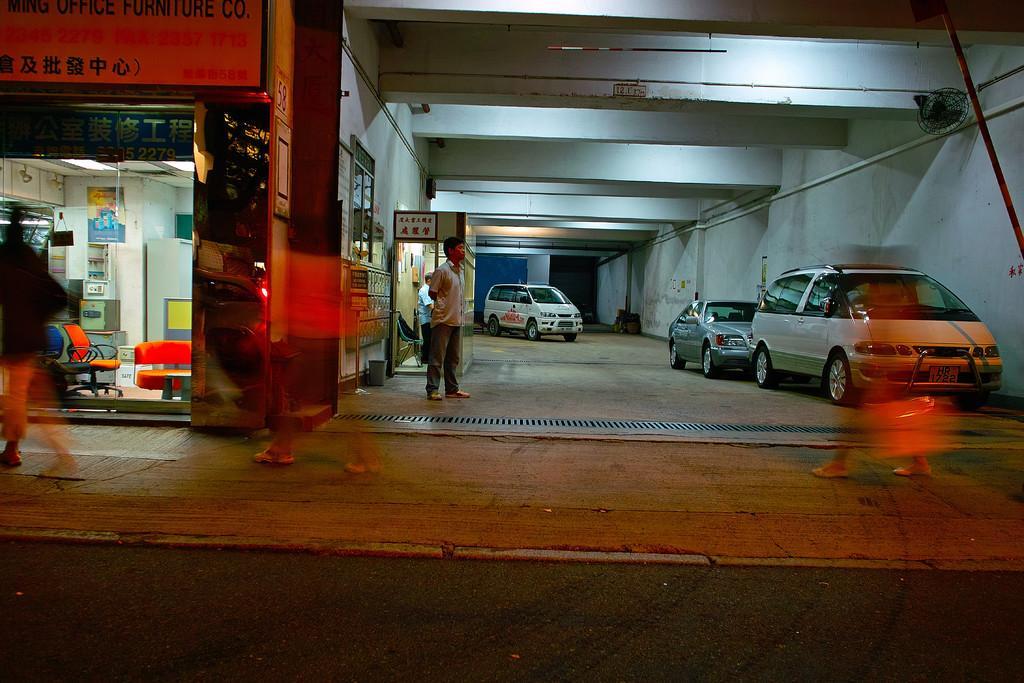Can you describe this image briefly? In this image it looks like it is a parking area in which there are three cars parked on the right side. On the left side it seems like it is a furniture store in which there are chairs,tables and some furniture items. There are few people walking on the footpath. In the middle there is a person standing on the floor. At the top there are lights. 